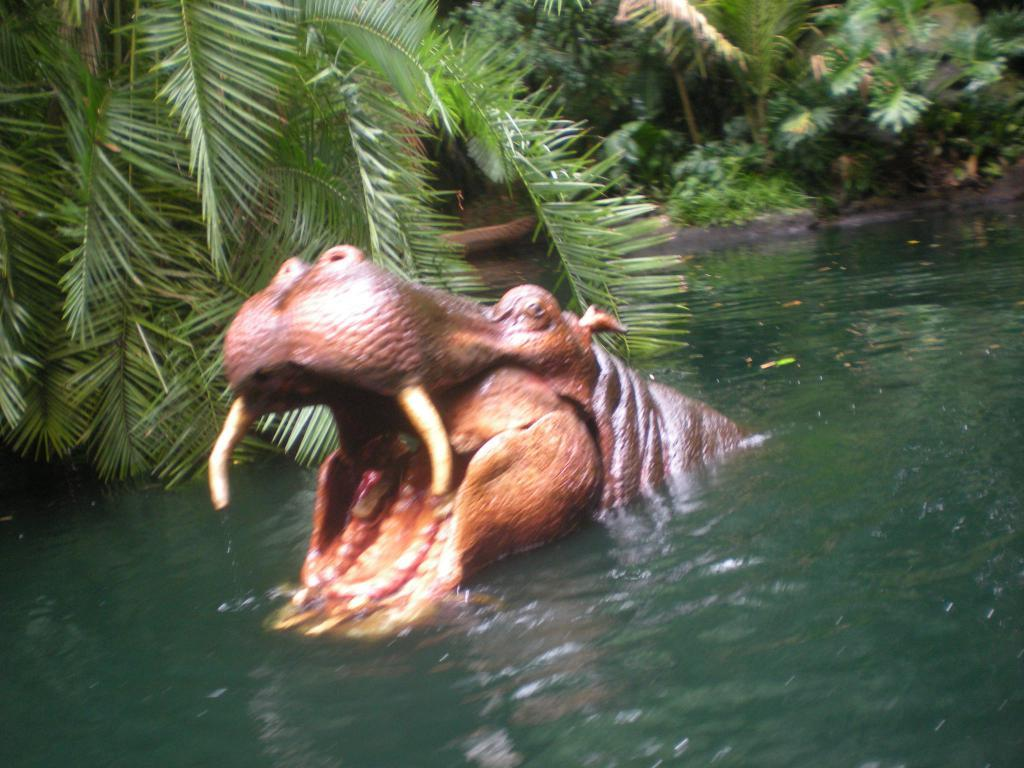What is the animal doing in the water in the image? The fact does not specify what the animal is doing, only that it is in the water. What type of environment is depicted in the image? The image features many trees, suggesting a natural or forested setting. What reward is the animal receiving in the afternoon in the image? There is no mention of a reward or the time of day in the image, so this question cannot be answered definitively. 